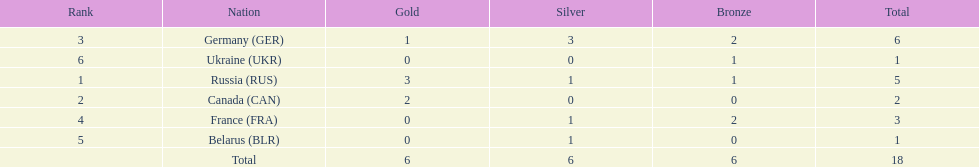Which nations participated? Russia (RUS), Canada (CAN), Germany (GER), France (FRA), Belarus (BLR), Ukraine (UKR). And how many gold medals did they win? 3, 2, 1, 0, 0, 0. What about silver medals? 1, 0, 3, 1, 1, 0. And bronze? 1, 0, 2, 2, 0, 1. Which nation only won gold medals? Canada (CAN). 